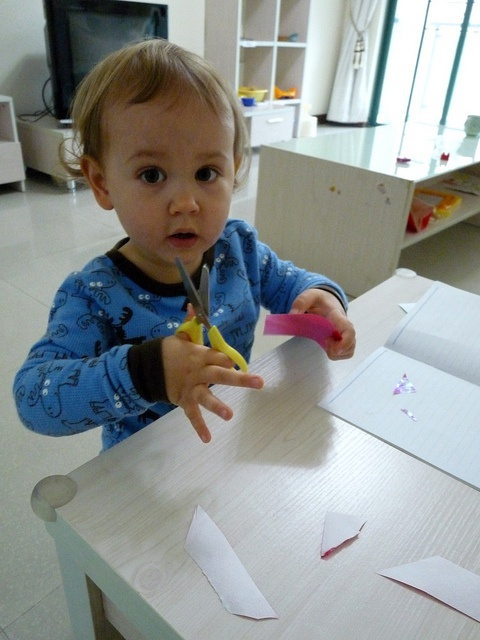Describe the objects in this image and their specific colors. I can see dining table in darkgray and lightgray tones, people in darkgray, maroon, black, blue, and gray tones, dining table in darkgray, gray, and white tones, book in darkgray and lightgray tones, and tv in darkgray, black, gray, purple, and darkblue tones in this image. 